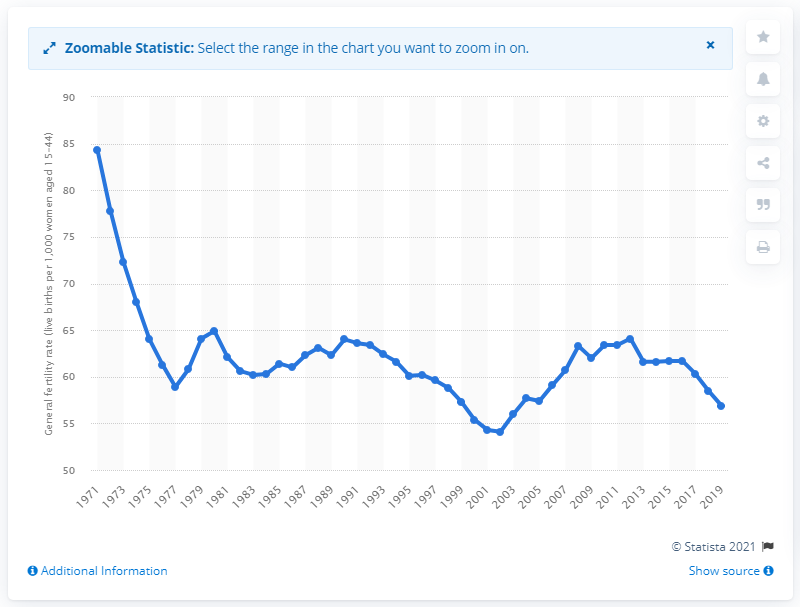Specify some key components in this picture. The general fertility rate in the UK in 2019 was 56.9. The highest fertility rate in 1971 was 84.3. 